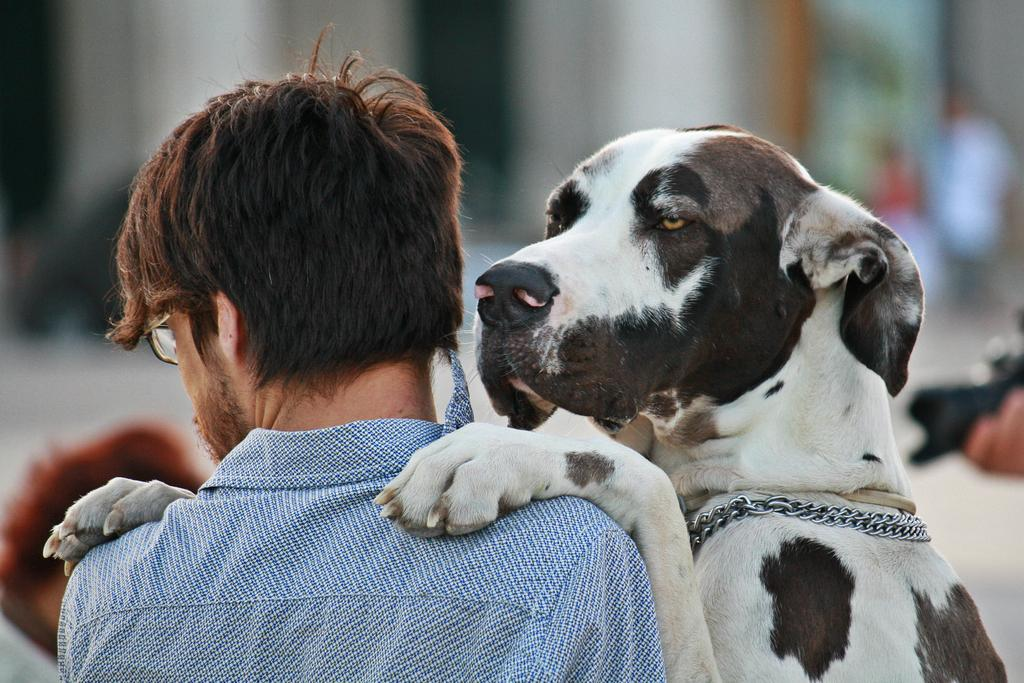What animal is present in the image? There is a dog in the image. How is the dog interacting with a person in the image? The dog has its first two legs on a person. Can you describe the position of the person in relation to the dog? There is a person standing in front of the dog. What type of cherry is the dog holding in its mouth in the image? There is no cherry present in the image; the dog has its first two legs on a person. 